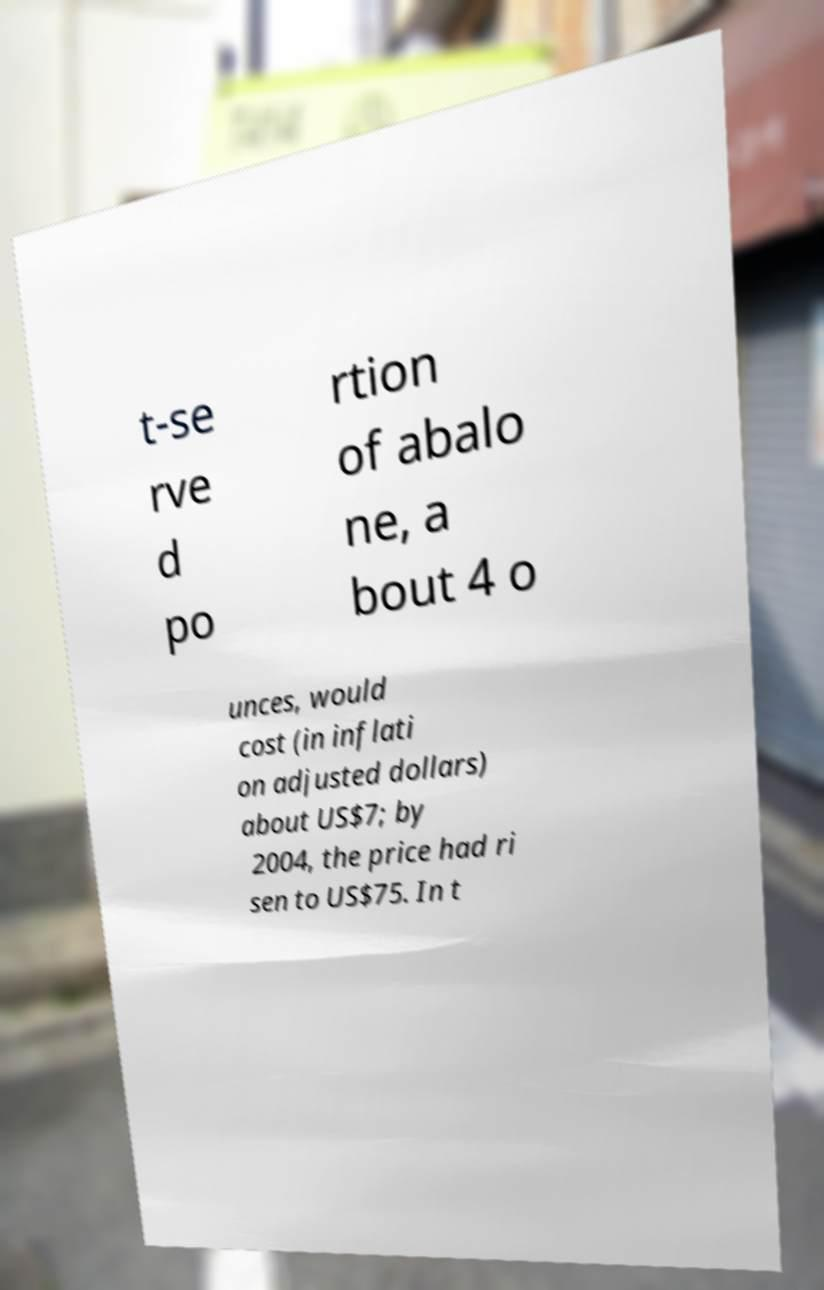Please identify and transcribe the text found in this image. t-se rve d po rtion of abalo ne, a bout 4 o unces, would cost (in inflati on adjusted dollars) about US$7; by 2004, the price had ri sen to US$75. In t 